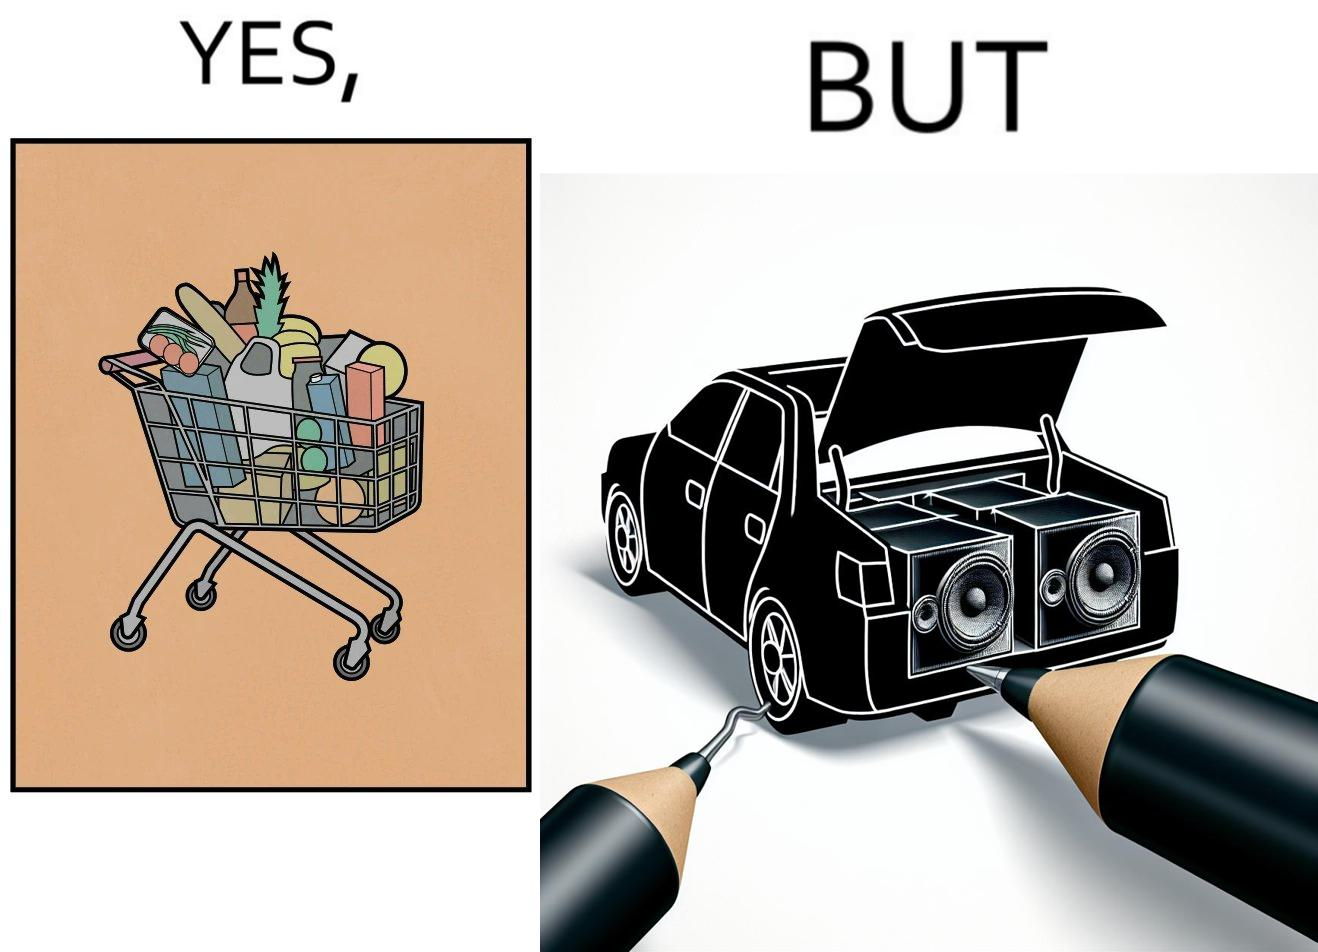Is this image satirical or non-satirical? Yes, this image is satirical. 